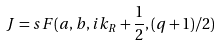Convert formula to latex. <formula><loc_0><loc_0><loc_500><loc_500>J = s F ( a , b , i k _ { R } + \frac { 1 } { 2 } , ( q + 1 ) / 2 )</formula> 